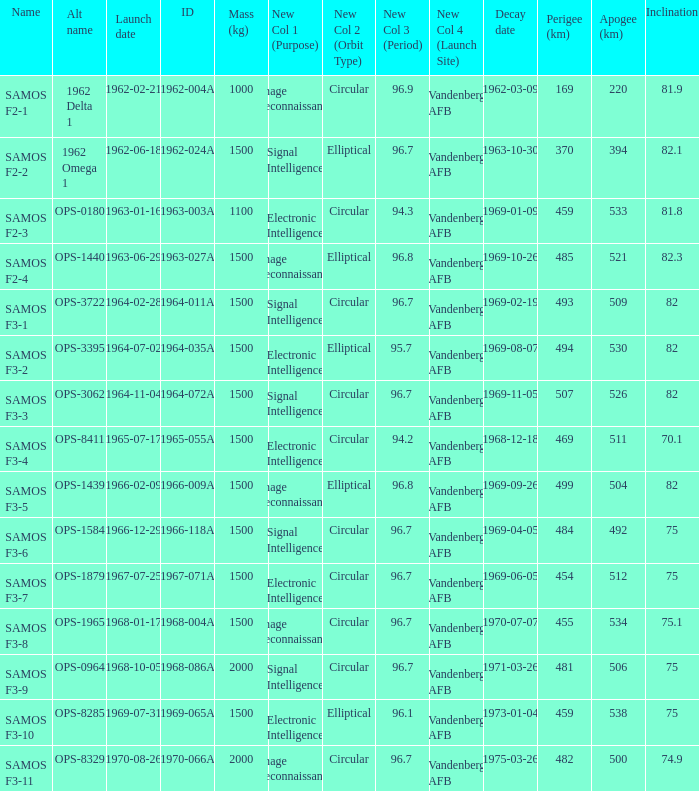What is the maximum apogee for samos f3-3? 526.0. 